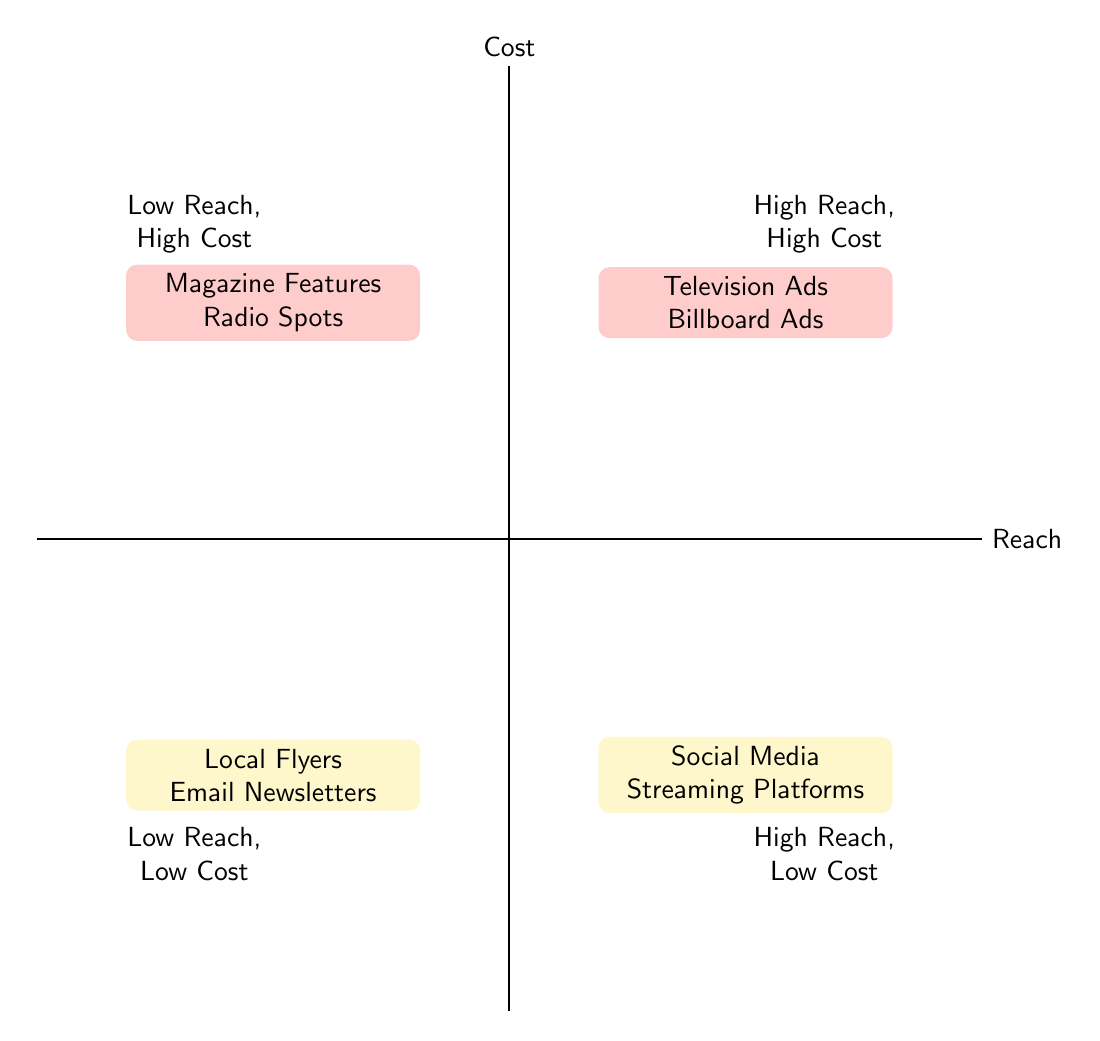What channels fall under High Reach, High Cost? The "High Reach, High Cost" quadrant lists "Television Ads" and "Billboard Advertisements." These are both promotional channels that require significant financial investment but are likely to reach a large audience.
Answer: Television Ads, Billboard Advertisements How many nodes are represented in the Low Reach, Low Cost quadrant? There are two promotional channels listed in the "Low Reach, Low Cost" quadrant: "Local Flyers" and "Email Newsletters." Counting these gives a total of two nodes.
Answer: 2 Which promotion channel has Low Reach and High Cost? The "Low Reach, High Cost" quadrant indicates the presence of "Magazine Features" and "Radio Spots." Identifying these channels confirms they fit the specified criteria.
Answer: Magazine Features, Radio Spots Name a channel with High Reach and Low Cost. In the "High Reach, Low Cost" quadrant, "Social Media Campaigns" and "Streaming Platforms" are present. Both options confirm that they are cost-effective while reaching a broad audience.
Answer: Social Media Campaigns, Streaming Platforms Which quadrant contains the most expensive promotional channels? The "High Reach, High Cost" and "Low Reach, High Cost" quadrants contain the most expensive promotional channels. "Television Ads" and "Billboard Advertisements" are in the former, while "Magazine Features" and "Radio Spots" are in the latter. Analyzing these quadrants shows they all depict high financial costs.
Answer: High Reach, High Cost; Low Reach, High Cost What is the relationship between Audience Reach and Cost for Email Newsletters? "Email Newsletters" are classified under the "Low Reach, Low Cost" quadrant, indicating that they are affordable but do not reach a wide audience. This reflects a trade-off between cost and reach.
Answer: Low Reach, Low Cost 